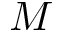<formula> <loc_0><loc_0><loc_500><loc_500>M</formula> 